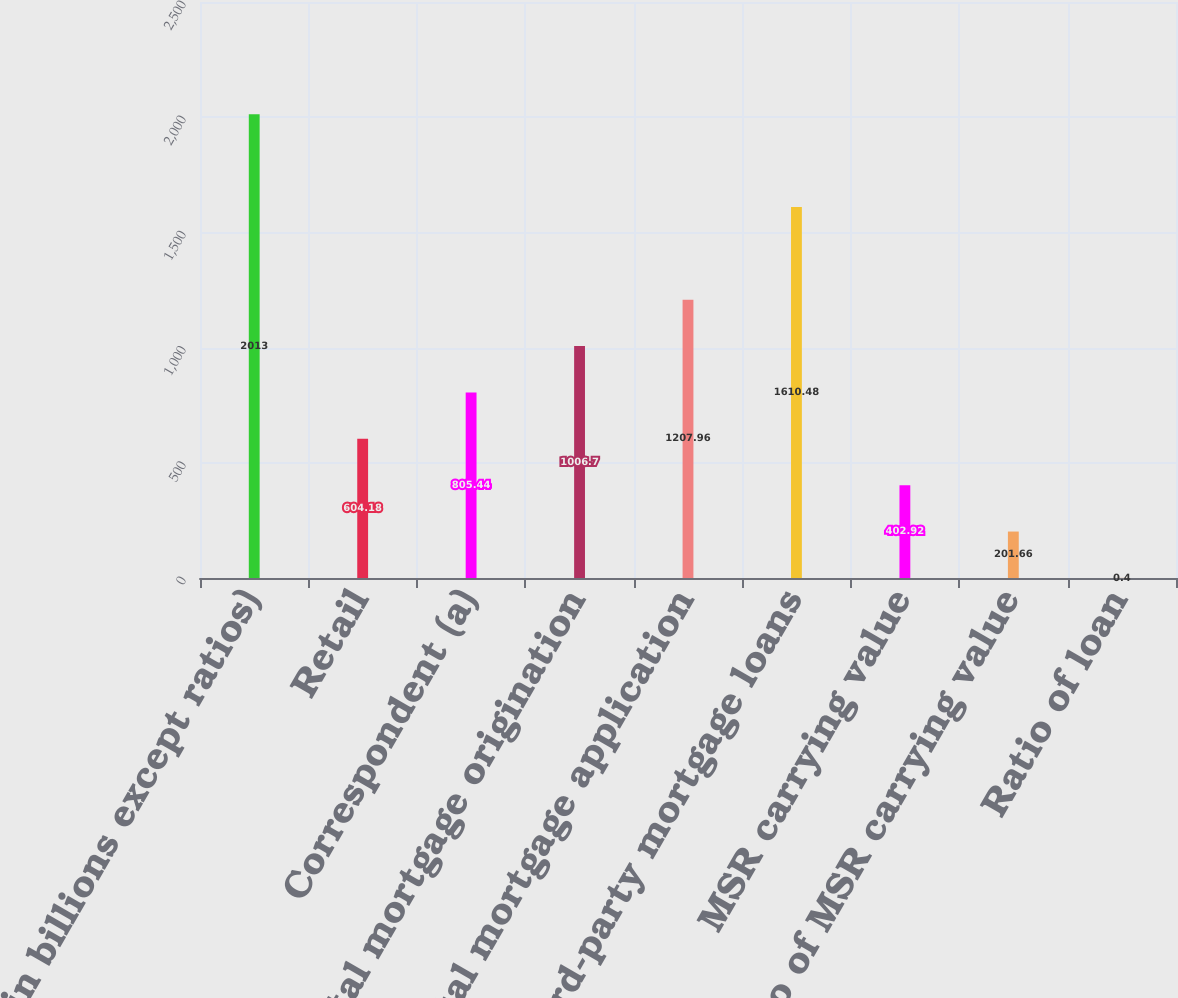Convert chart. <chart><loc_0><loc_0><loc_500><loc_500><bar_chart><fcel>(in billions except ratios)<fcel>Retail<fcel>Correspondent (a)<fcel>Total mortgage origination<fcel>Total mortgage application<fcel>Third-party mortgage loans<fcel>MSR carrying value<fcel>Ratio of MSR carrying value<fcel>Ratio of loan<nl><fcel>2013<fcel>604.18<fcel>805.44<fcel>1006.7<fcel>1207.96<fcel>1610.48<fcel>402.92<fcel>201.66<fcel>0.4<nl></chart> 